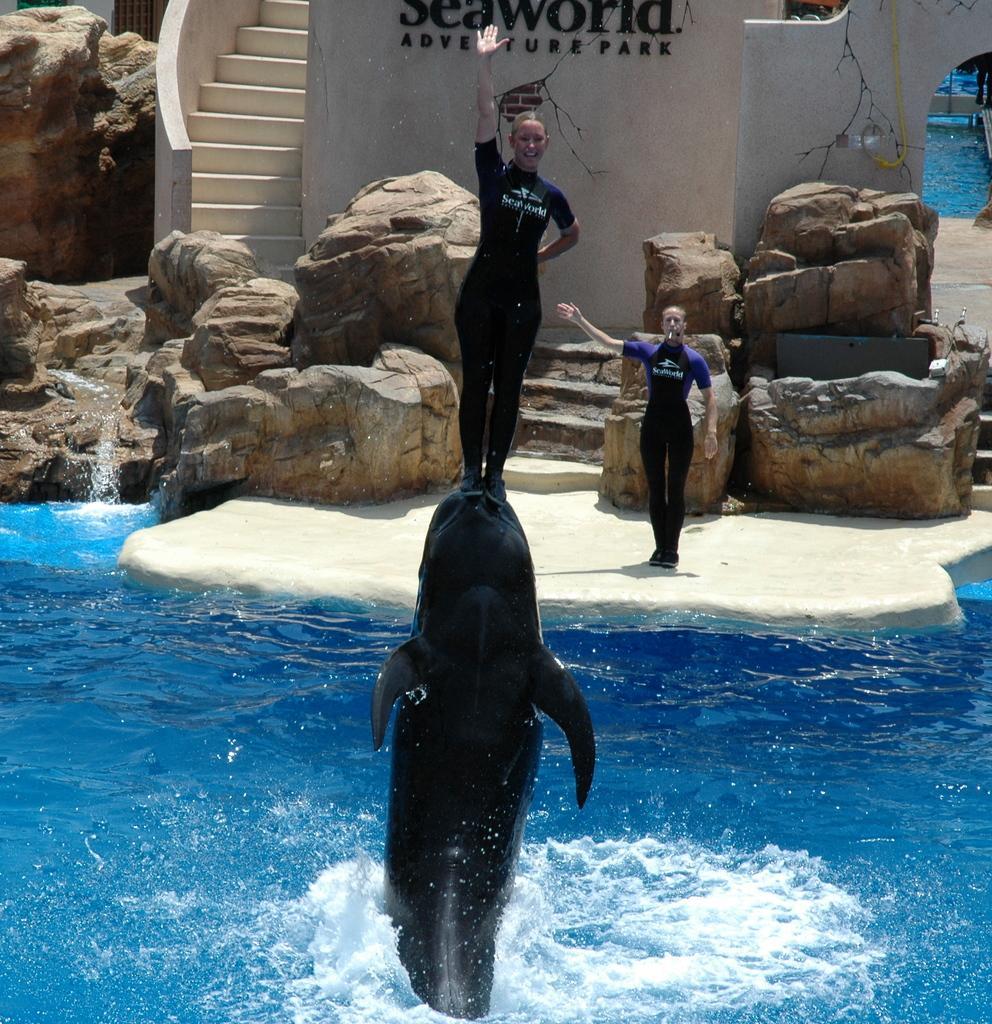Could you give a brief overview of what you see in this image? In this image we can see two people, a dolphin in water a person standing on the dolphin in the background there are some stones, stairs and wall and some text written on the wall. 